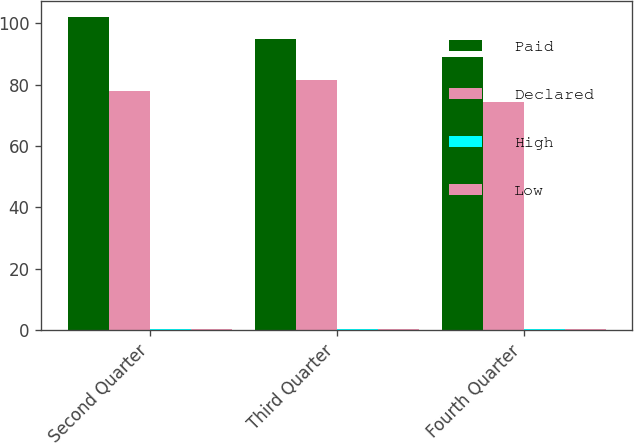Convert chart. <chart><loc_0><loc_0><loc_500><loc_500><stacked_bar_chart><ecel><fcel>Second Quarter<fcel>Third Quarter<fcel>Fourth Quarter<nl><fcel>Paid<fcel>102.13<fcel>94.87<fcel>89.08<nl><fcel>Declared<fcel>77.93<fcel>81.55<fcel>74.5<nl><fcel>High<fcel>0.17<fcel>0.17<fcel>0.17<nl><fcel>Low<fcel>0.17<fcel>0.17<fcel>0.17<nl></chart> 